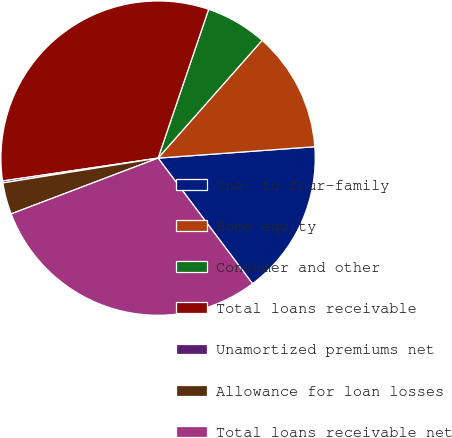Convert chart. <chart><loc_0><loc_0><loc_500><loc_500><pie_chart><fcel>One- to four-family<fcel>Home equity<fcel>Consumer and other<fcel>Total loans receivable<fcel>Unamortized premiums net<fcel>Allowance for loan losses<fcel>Total loans receivable net<nl><fcel>15.89%<fcel>12.33%<fcel>6.3%<fcel>32.54%<fcel>0.2%<fcel>3.25%<fcel>29.49%<nl></chart> 